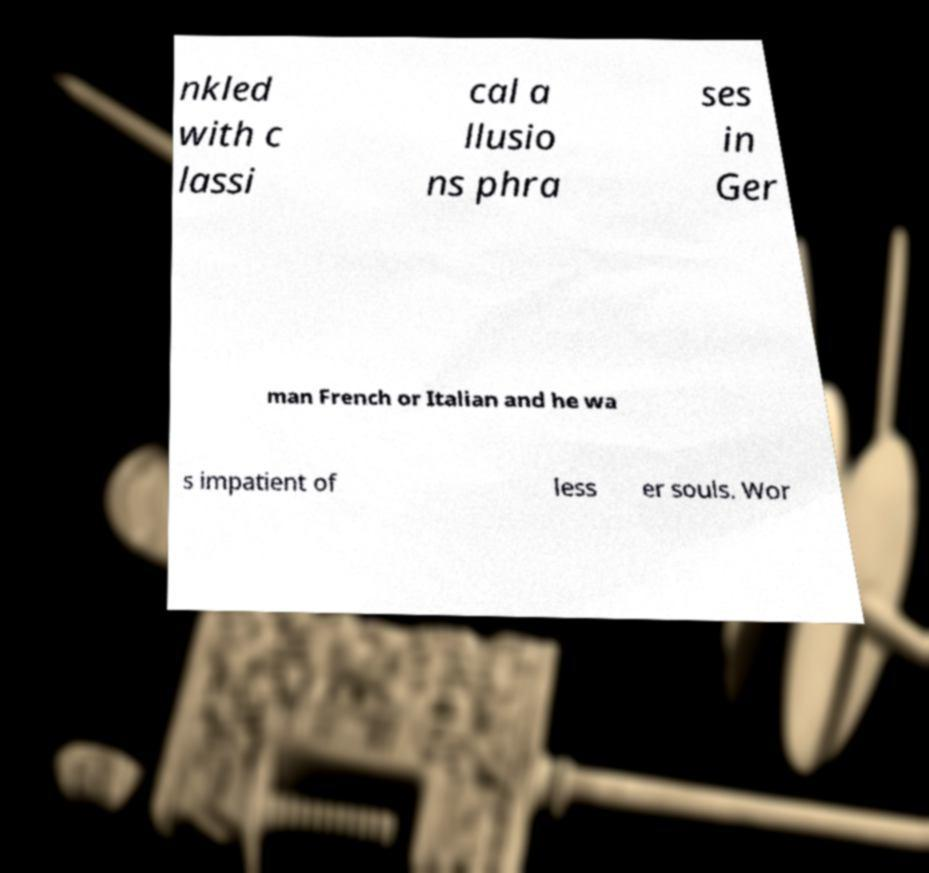I need the written content from this picture converted into text. Can you do that? nkled with c lassi cal a llusio ns phra ses in Ger man French or Italian and he wa s impatient of less er souls. Wor 